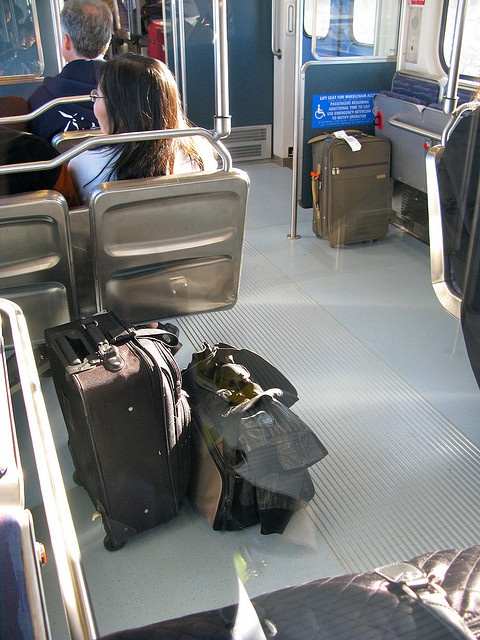Describe the objects in this image and their specific colors. I can see chair in blue, gray, and black tones, suitcase in blue, black, white, gray, and darkgray tones, backpack in blue, black, gray, and white tones, people in blue, black, white, gray, and darkgray tones, and suitcase in blue, gray, and black tones in this image. 